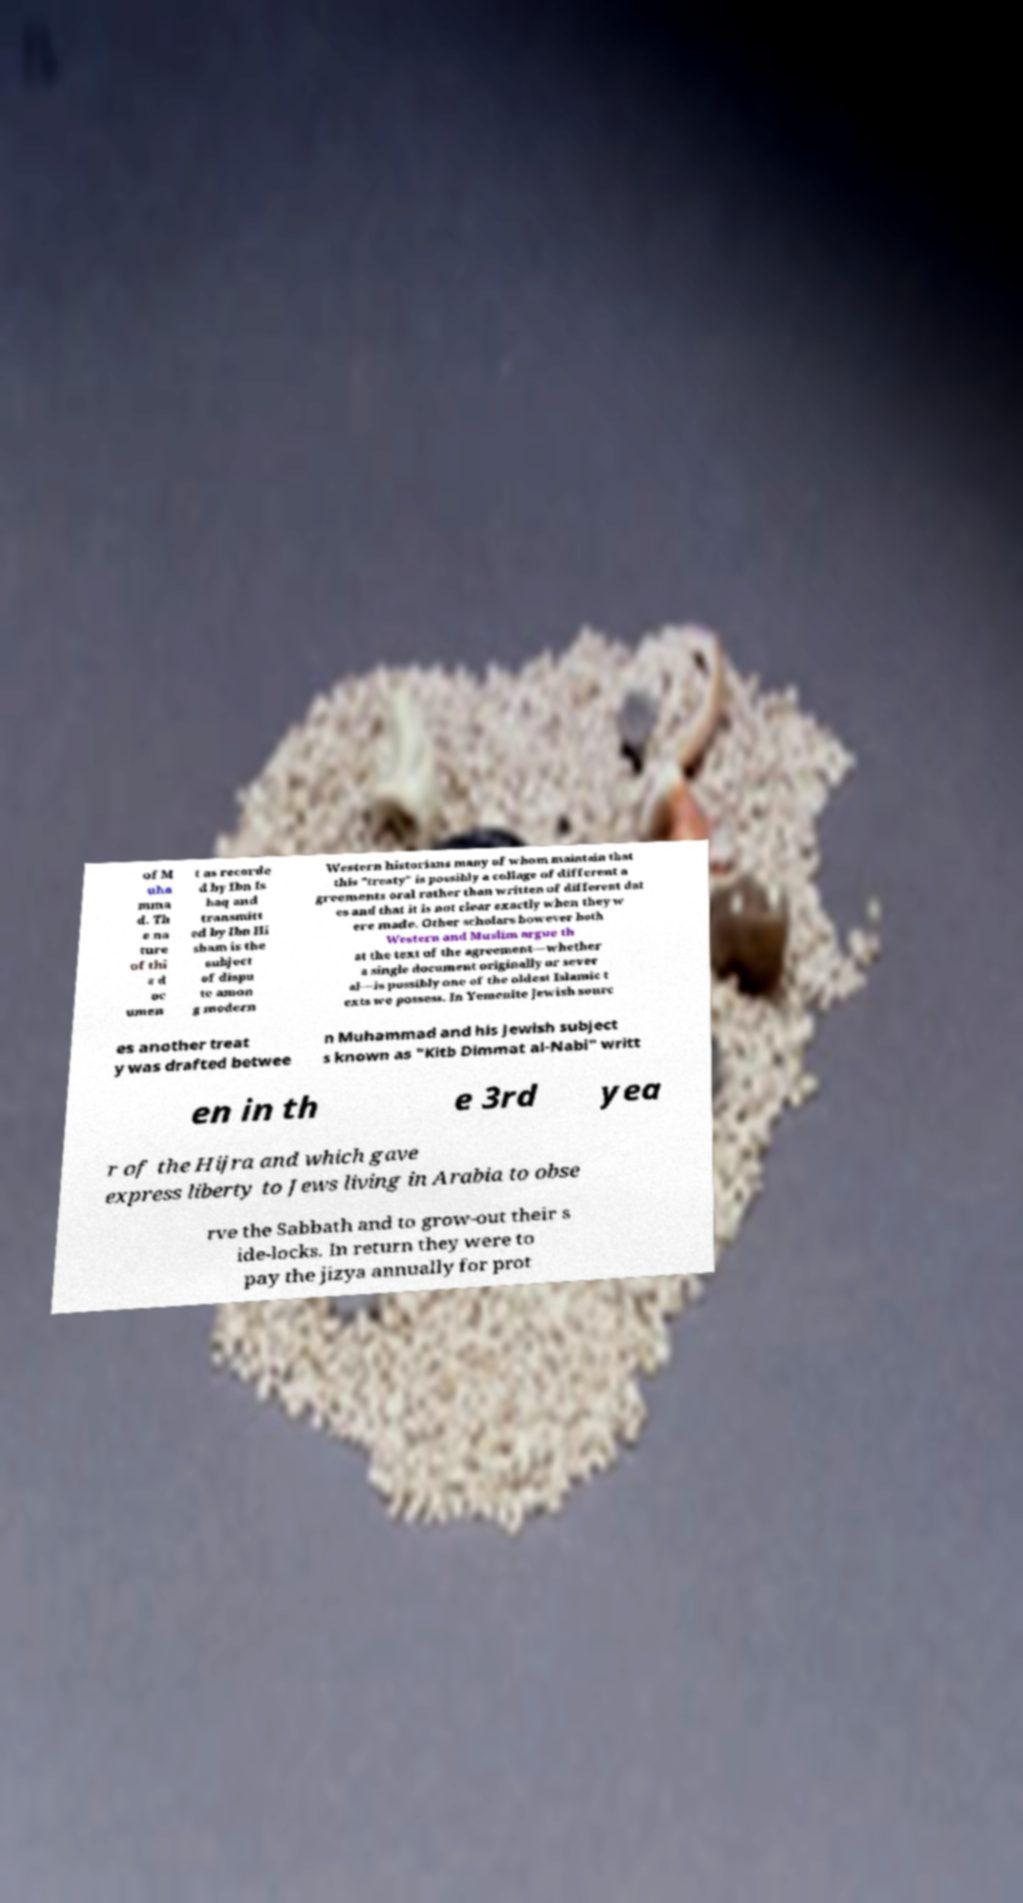For documentation purposes, I need the text within this image transcribed. Could you provide that? of M uha mma d. Th e na ture of thi s d oc umen t as recorde d by Ibn Is haq and transmitt ed by Ibn Hi sham is the subject of dispu te amon g modern Western historians many of whom maintain that this "treaty" is possibly a collage of different a greements oral rather than written of different dat es and that it is not clear exactly when they w ere made. Other scholars however both Western and Muslim argue th at the text of the agreement—whether a single document originally or sever al—is possibly one of the oldest Islamic t exts we possess. In Yemenite Jewish sourc es another treat y was drafted betwee n Muhammad and his Jewish subject s known as "Kitb Dimmat al-Nabi" writt en in th e 3rd yea r of the Hijra and which gave express liberty to Jews living in Arabia to obse rve the Sabbath and to grow-out their s ide-locks. In return they were to pay the jizya annually for prot 